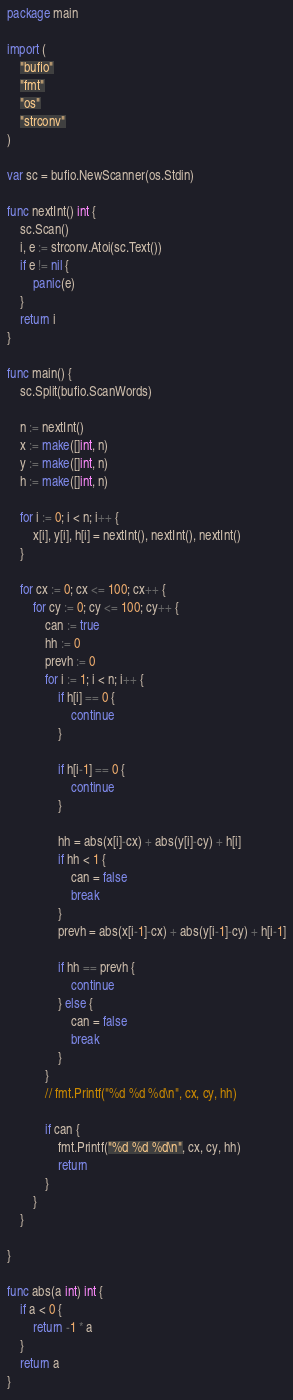<code> <loc_0><loc_0><loc_500><loc_500><_Go_>package main

import (
	"bufio"
	"fmt"
	"os"
	"strconv"
)

var sc = bufio.NewScanner(os.Stdin)

func nextInt() int {
	sc.Scan()
	i, e := strconv.Atoi(sc.Text())
	if e != nil {
		panic(e)
	}
	return i
}

func main() {
	sc.Split(bufio.ScanWords)

	n := nextInt()
	x := make([]int, n)
	y := make([]int, n)
	h := make([]int, n)

	for i := 0; i < n; i++ {
		x[i], y[i], h[i] = nextInt(), nextInt(), nextInt()
	}

	for cx := 0; cx <= 100; cx++ {
		for cy := 0; cy <= 100; cy++ {
			can := true
			hh := 0
			prevh := 0
			for i := 1; i < n; i++ {
				if h[i] == 0 {
					continue
				}

				if h[i-1] == 0 {
					continue
				}

				hh = abs(x[i]-cx) + abs(y[i]-cy) + h[i]
				if hh < 1 {
					can = false
					break
				}
				prevh = abs(x[i-1]-cx) + abs(y[i-1]-cy) + h[i-1]

				if hh == prevh {
					continue
				} else {
					can = false
					break
				}
			}
			// fmt.Printf("%d %d %d\n", cx, cy, hh)

			if can {
				fmt.Printf("%d %d %d\n", cx, cy, hh)
				return
			}
		}
	}

}

func abs(a int) int {
	if a < 0 {
		return -1 * a
	}
	return a
}
</code> 